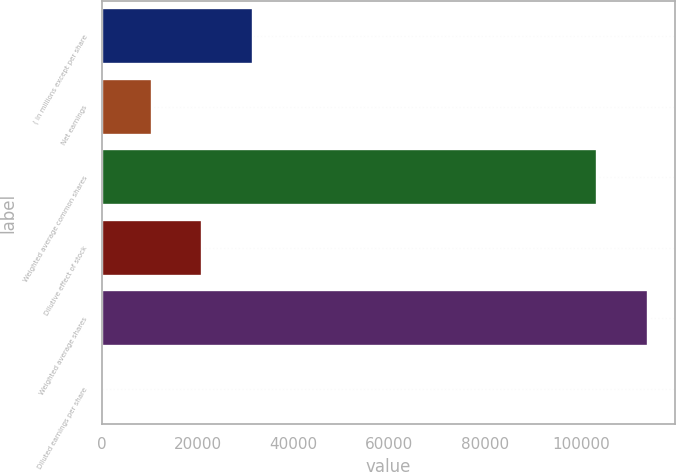Convert chart. <chart><loc_0><loc_0><loc_500><loc_500><bar_chart><fcel>( in millions except per share<fcel>Net earnings<fcel>Weighted average common shares<fcel>Dilutive effect of stock<fcel>Weighted average shares<fcel>Diluted earnings per share<nl><fcel>31487.5<fcel>10497.9<fcel>103338<fcel>20992.7<fcel>113833<fcel>3.14<nl></chart> 